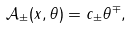<formula> <loc_0><loc_0><loc_500><loc_500>\mathcal { A } _ { \pm } ( x , \theta ) = c _ { \pm } \theta ^ { \mp } ,</formula> 